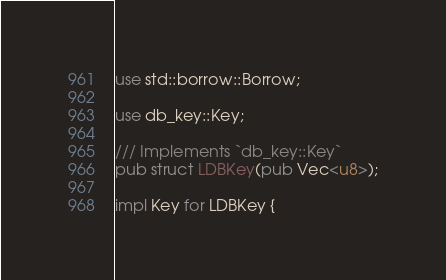<code> <loc_0><loc_0><loc_500><loc_500><_Rust_>use std::borrow::Borrow;

use db_key::Key;

/// Implements `db_key::Key`
pub struct LDBKey(pub Vec<u8>);

impl Key for LDBKey {</code> 